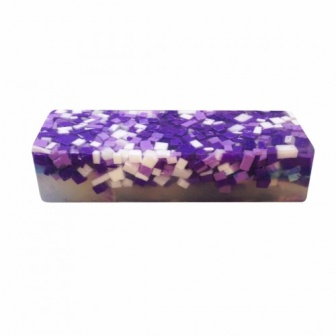What can you tell me about the colors used in this soap? The colors used in this soap are primarily various shades of purple and white. The diverse purples range from deep, rich hues to lighter, more pastel tones. The white tiles provide a striking contrast against the purple shades, making the overall design pop. This combination gives the soap a sophisticated and elegant appearance. Why do you think these colors were chosen for this soap design? The choice of purple and white could be deliberate for several reasons. Purple is often associated with luxury, calmness, and creativity. It could be chosen to induce a sense of relaxation and pampering, fitting well with the purpose of a soap. White, on the other hand, symbolizes purity and cleanliness, which are qualities tied directly to soap's primary function. Together, they create an appealing aesthetic that combines both serenity and efficiency. 